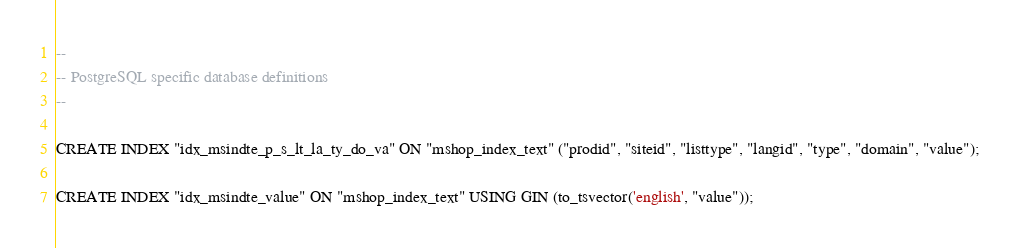<code> <loc_0><loc_0><loc_500><loc_500><_SQL_>--
-- PostgreSQL specific database definitions
--

CREATE INDEX "idx_msindte_p_s_lt_la_ty_do_va" ON "mshop_index_text" ("prodid", "siteid", "listtype", "langid", "type", "domain", "value");

CREATE INDEX "idx_msindte_value" ON "mshop_index_text" USING GIN (to_tsvector('english', "value"));
</code> 